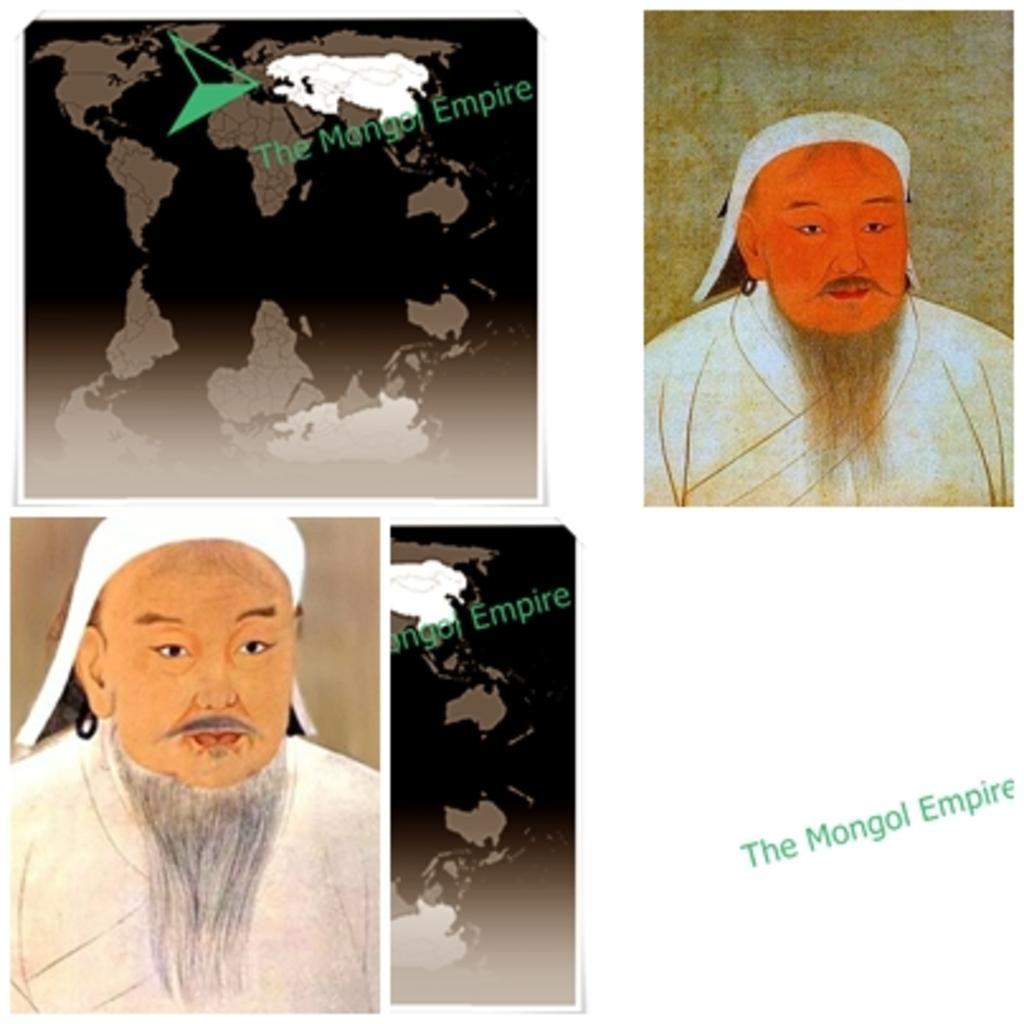Can you describe this image briefly? This is a screen having texts, two maps and two paintings of a person. And the background of this screen is white in color. 